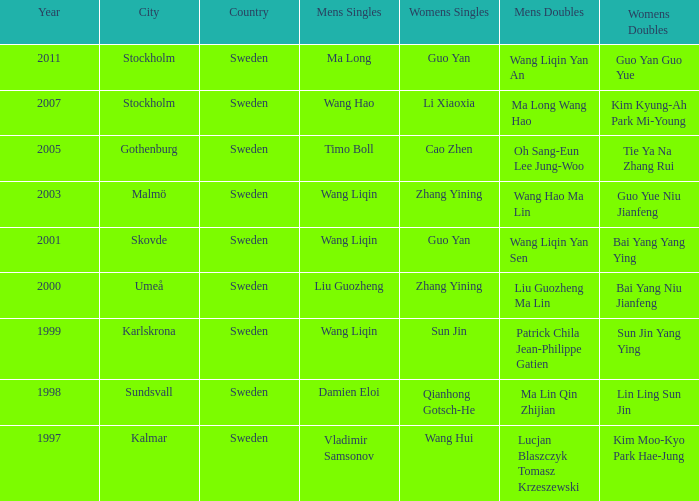How many times has Sun Jin won the women's doubles? 1.0. 